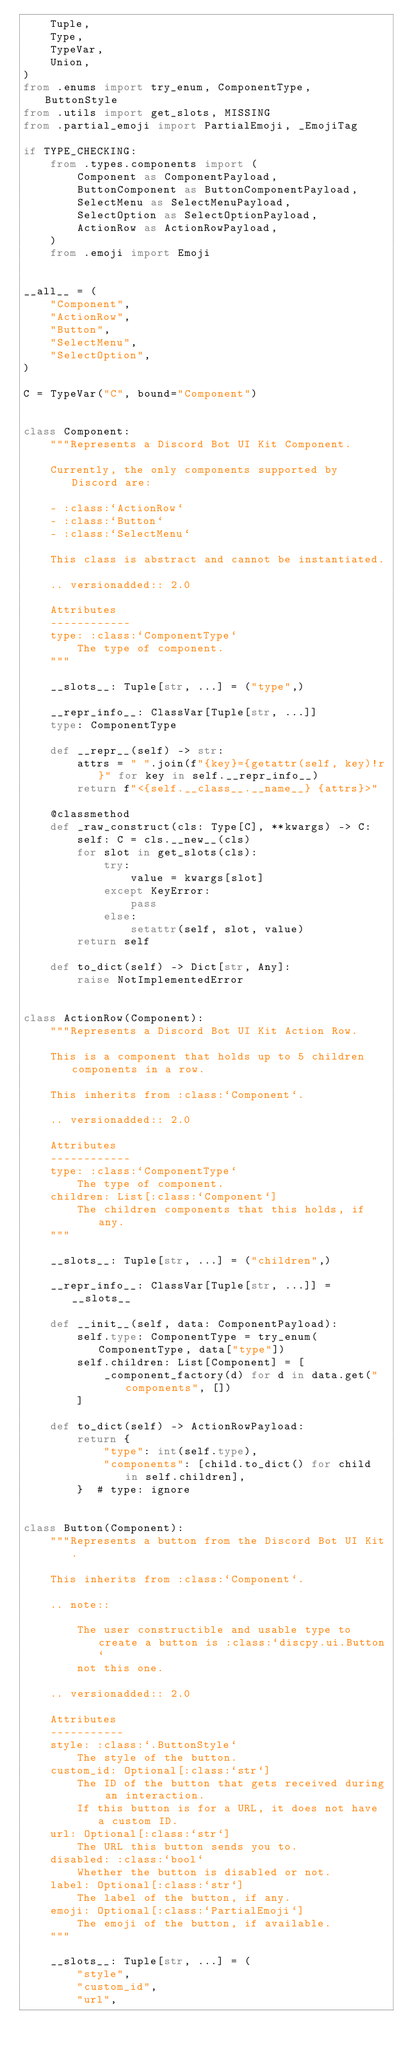<code> <loc_0><loc_0><loc_500><loc_500><_Python_>    Tuple,
    Type,
    TypeVar,
    Union,
)
from .enums import try_enum, ComponentType, ButtonStyle
from .utils import get_slots, MISSING
from .partial_emoji import PartialEmoji, _EmojiTag

if TYPE_CHECKING:
    from .types.components import (
        Component as ComponentPayload,
        ButtonComponent as ButtonComponentPayload,
        SelectMenu as SelectMenuPayload,
        SelectOption as SelectOptionPayload,
        ActionRow as ActionRowPayload,
    )
    from .emoji import Emoji


__all__ = (
    "Component",
    "ActionRow",
    "Button",
    "SelectMenu",
    "SelectOption",
)

C = TypeVar("C", bound="Component")


class Component:
    """Represents a Discord Bot UI Kit Component.

    Currently, the only components supported by Discord are:

    - :class:`ActionRow`
    - :class:`Button`
    - :class:`SelectMenu`

    This class is abstract and cannot be instantiated.

    .. versionadded:: 2.0

    Attributes
    ------------
    type: :class:`ComponentType`
        The type of component.
    """

    __slots__: Tuple[str, ...] = ("type",)

    __repr_info__: ClassVar[Tuple[str, ...]]
    type: ComponentType

    def __repr__(self) -> str:
        attrs = " ".join(f"{key}={getattr(self, key)!r}" for key in self.__repr_info__)
        return f"<{self.__class__.__name__} {attrs}>"

    @classmethod
    def _raw_construct(cls: Type[C], **kwargs) -> C:
        self: C = cls.__new__(cls)
        for slot in get_slots(cls):
            try:
                value = kwargs[slot]
            except KeyError:
                pass
            else:
                setattr(self, slot, value)
        return self

    def to_dict(self) -> Dict[str, Any]:
        raise NotImplementedError


class ActionRow(Component):
    """Represents a Discord Bot UI Kit Action Row.

    This is a component that holds up to 5 children components in a row.

    This inherits from :class:`Component`.

    .. versionadded:: 2.0

    Attributes
    ------------
    type: :class:`ComponentType`
        The type of component.
    children: List[:class:`Component`]
        The children components that this holds, if any.
    """

    __slots__: Tuple[str, ...] = ("children",)

    __repr_info__: ClassVar[Tuple[str, ...]] = __slots__

    def __init__(self, data: ComponentPayload):
        self.type: ComponentType = try_enum(ComponentType, data["type"])
        self.children: List[Component] = [
            _component_factory(d) for d in data.get("components", [])
        ]

    def to_dict(self) -> ActionRowPayload:
        return {
            "type": int(self.type),
            "components": [child.to_dict() for child in self.children],
        }  # type: ignore


class Button(Component):
    """Represents a button from the Discord Bot UI Kit.

    This inherits from :class:`Component`.

    .. note::

        The user constructible and usable type to create a button is :class:`discpy.ui.Button`
        not this one.

    .. versionadded:: 2.0

    Attributes
    -----------
    style: :class:`.ButtonStyle`
        The style of the button.
    custom_id: Optional[:class:`str`]
        The ID of the button that gets received during an interaction.
        If this button is for a URL, it does not have a custom ID.
    url: Optional[:class:`str`]
        The URL this button sends you to.
    disabled: :class:`bool`
        Whether the button is disabled or not.
    label: Optional[:class:`str`]
        The label of the button, if any.
    emoji: Optional[:class:`PartialEmoji`]
        The emoji of the button, if available.
    """

    __slots__: Tuple[str, ...] = (
        "style",
        "custom_id",
        "url",</code> 